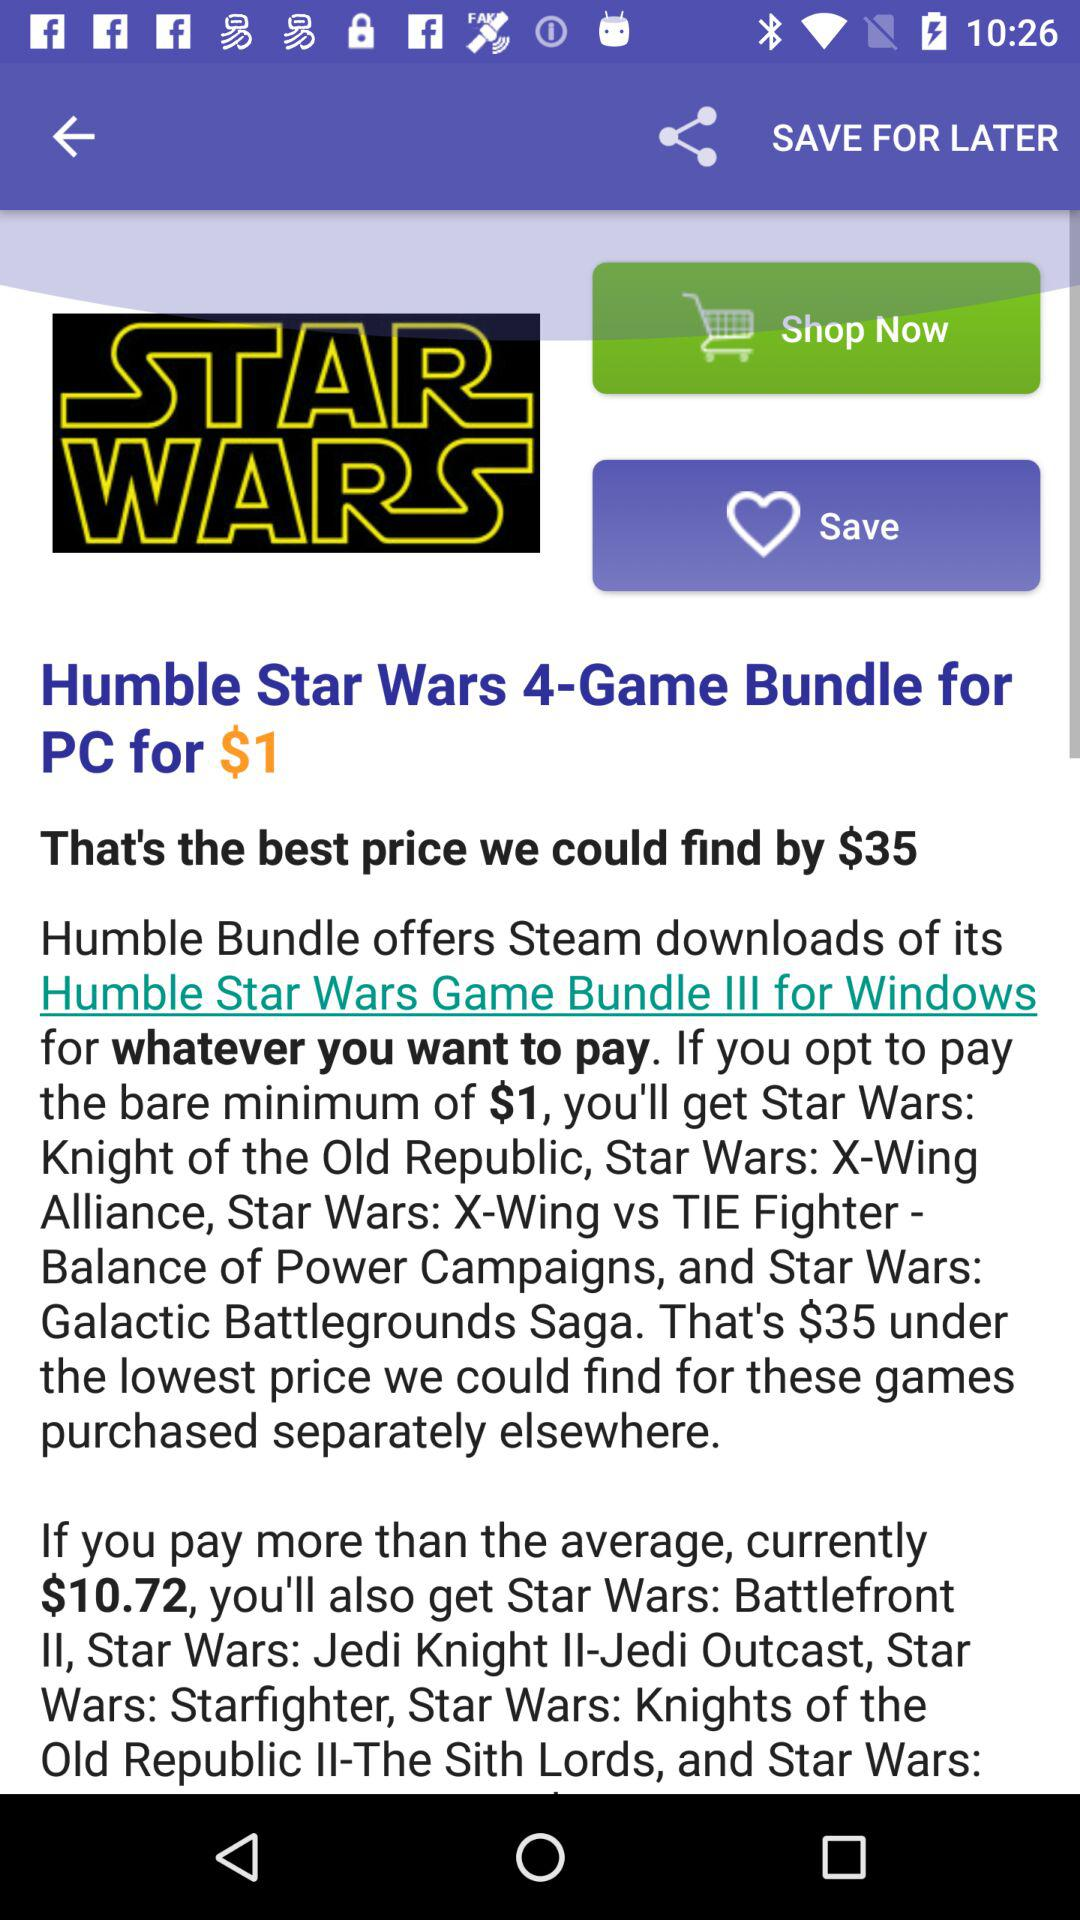What is the price for the "Humble Star Wars 4-Game Bundle"? The price for the "Humble Star Wars 4-Game Bundle" is $1. 